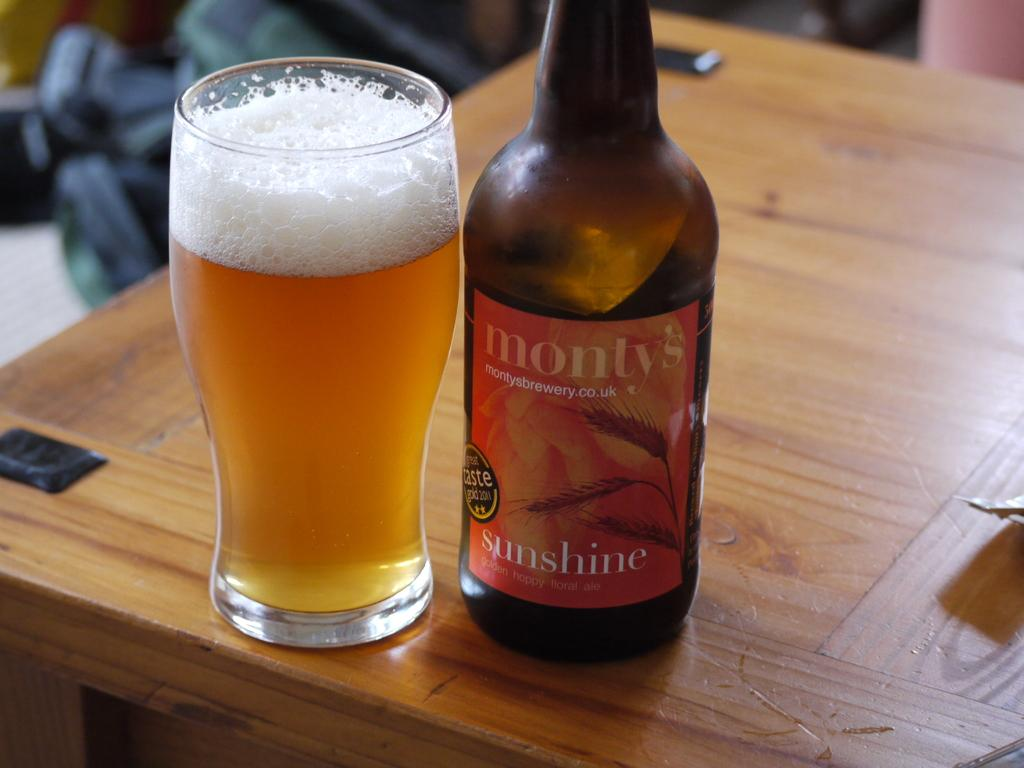What piece of furniture is present in the image? There is a table in the image. What object can be seen on the table? There is a bottle on the table. What else is on the table besides the bottle? There is a glass containing a beverage on the table. How many family members are present in the image? There is no indication of family members in the image; it only shows a table with a bottle and a glass containing a beverage. Can you see a giraffe in the image? No, there is no giraffe present in the image. 